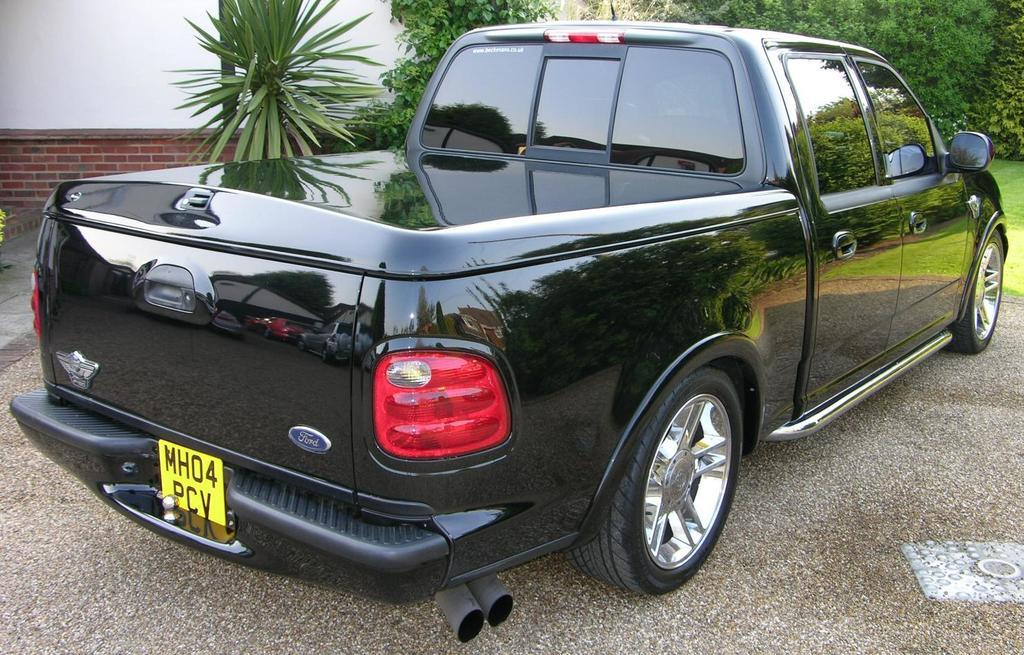What is the main subject in the center of the image? There is a car in the center of the image. What is located at the bottom of the image? There is a road at the bottom of the image. What can be seen in the background of the image? There is a house, trees, plants, and grass in the background of the image. Where is the basket located in the image? There is no basket present in the image. What type of observation can be made about the bone in the image? There is no bone present in the image. 